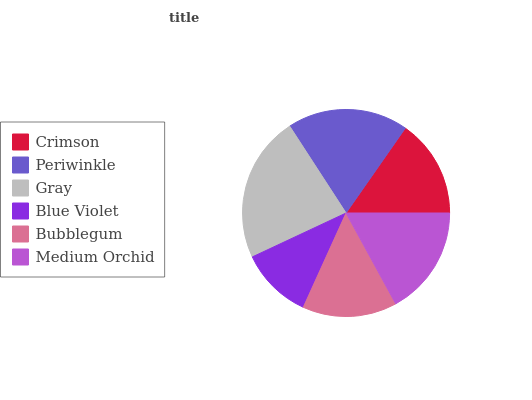Is Blue Violet the minimum?
Answer yes or no. Yes. Is Gray the maximum?
Answer yes or no. Yes. Is Periwinkle the minimum?
Answer yes or no. No. Is Periwinkle the maximum?
Answer yes or no. No. Is Periwinkle greater than Crimson?
Answer yes or no. Yes. Is Crimson less than Periwinkle?
Answer yes or no. Yes. Is Crimson greater than Periwinkle?
Answer yes or no. No. Is Periwinkle less than Crimson?
Answer yes or no. No. Is Medium Orchid the high median?
Answer yes or no. Yes. Is Crimson the low median?
Answer yes or no. Yes. Is Blue Violet the high median?
Answer yes or no. No. Is Periwinkle the low median?
Answer yes or no. No. 